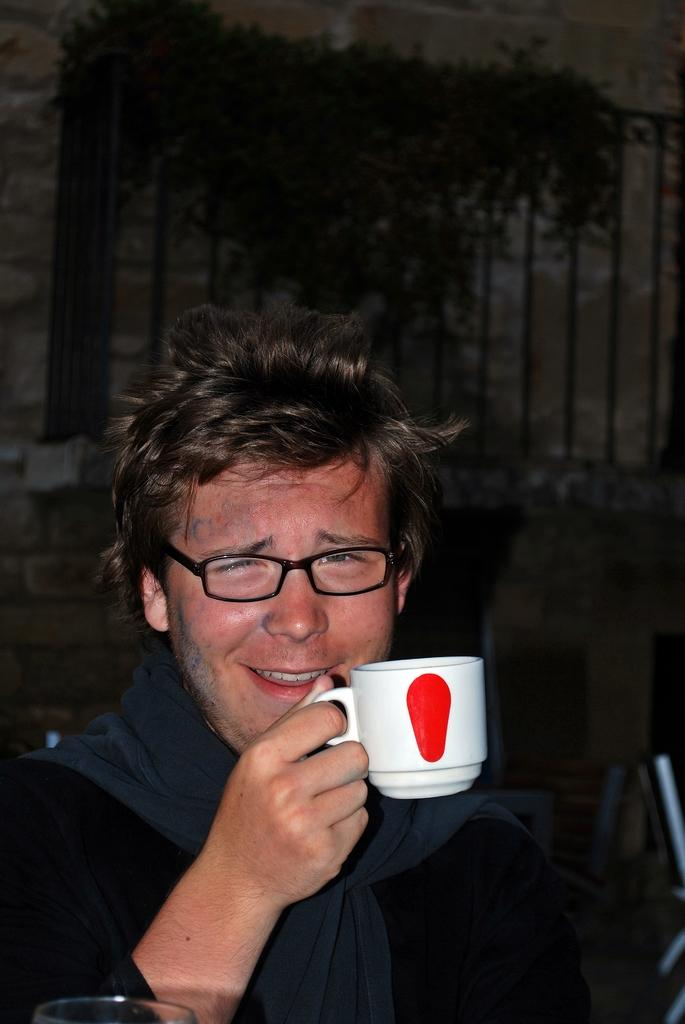Who is present in the image? There is a man in the image. What is the man doing in the image? The man is smiling in the image. What is the man holding in the image? The man is holding a cup in the image. What can be seen in the background of the image? There is a wall and plants in the background of the image. What scent can be detected from the family in the image? There is no mention of a family in the image, and therefore no scent can be detected from them. 